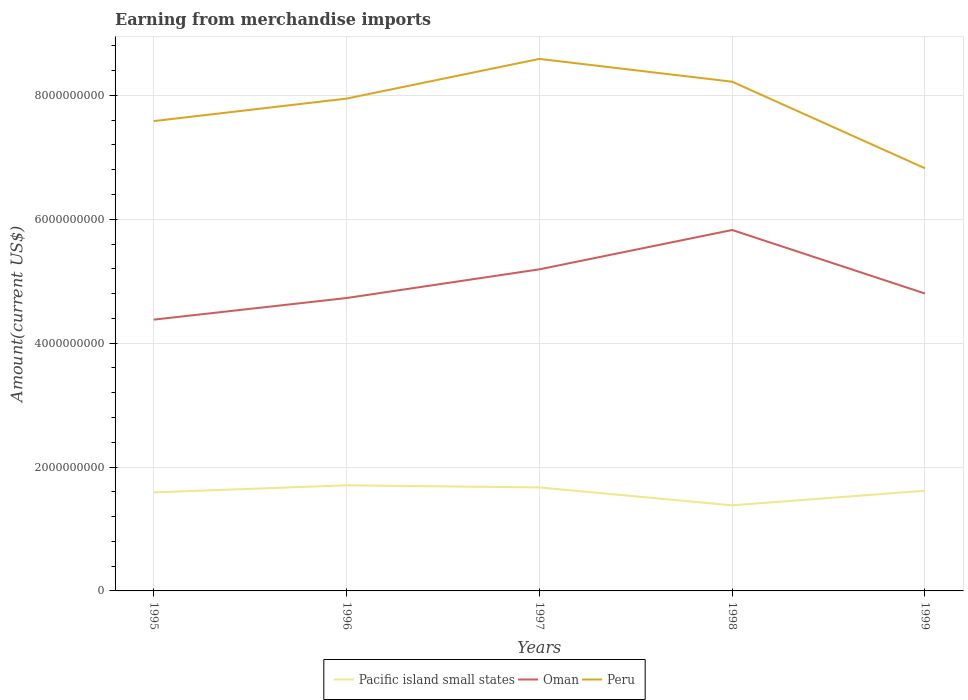How many different coloured lines are there?
Make the answer very short. 3. Does the line corresponding to Oman intersect with the line corresponding to Peru?
Keep it short and to the point. No. Is the number of lines equal to the number of legend labels?
Your answer should be very brief. Yes. Across all years, what is the maximum amount earned from merchandise imports in Pacific island small states?
Keep it short and to the point. 1.38e+09. In which year was the amount earned from merchandise imports in Pacific island small states maximum?
Your answer should be compact. 1998. What is the total amount earned from merchandise imports in Pacific island small states in the graph?
Provide a succinct answer. 2.89e+08. What is the difference between the highest and the second highest amount earned from merchandise imports in Oman?
Your answer should be compact. 1.45e+09. What is the difference between the highest and the lowest amount earned from merchandise imports in Pacific island small states?
Offer a terse response. 3. How many years are there in the graph?
Give a very brief answer. 5. What is the difference between two consecutive major ticks on the Y-axis?
Give a very brief answer. 2.00e+09. Does the graph contain any zero values?
Keep it short and to the point. No. Does the graph contain grids?
Provide a succinct answer. Yes. How are the legend labels stacked?
Keep it short and to the point. Horizontal. What is the title of the graph?
Make the answer very short. Earning from merchandise imports. What is the label or title of the X-axis?
Provide a short and direct response. Years. What is the label or title of the Y-axis?
Ensure brevity in your answer.  Amount(current US$). What is the Amount(current US$) in Pacific island small states in 1995?
Your answer should be compact. 1.59e+09. What is the Amount(current US$) in Oman in 1995?
Offer a terse response. 4.38e+09. What is the Amount(current US$) of Peru in 1995?
Your answer should be very brief. 7.58e+09. What is the Amount(current US$) of Pacific island small states in 1996?
Your answer should be very brief. 1.70e+09. What is the Amount(current US$) of Oman in 1996?
Your answer should be very brief. 4.73e+09. What is the Amount(current US$) of Peru in 1996?
Make the answer very short. 7.95e+09. What is the Amount(current US$) of Pacific island small states in 1997?
Your answer should be compact. 1.67e+09. What is the Amount(current US$) of Oman in 1997?
Your answer should be compact. 5.19e+09. What is the Amount(current US$) in Peru in 1997?
Your response must be concise. 8.59e+09. What is the Amount(current US$) of Pacific island small states in 1998?
Make the answer very short. 1.38e+09. What is the Amount(current US$) of Oman in 1998?
Offer a very short reply. 5.83e+09. What is the Amount(current US$) in Peru in 1998?
Ensure brevity in your answer.  8.22e+09. What is the Amount(current US$) in Pacific island small states in 1999?
Offer a very short reply. 1.62e+09. What is the Amount(current US$) of Oman in 1999?
Keep it short and to the point. 4.80e+09. What is the Amount(current US$) of Peru in 1999?
Your response must be concise. 6.82e+09. Across all years, what is the maximum Amount(current US$) in Pacific island small states?
Your answer should be compact. 1.70e+09. Across all years, what is the maximum Amount(current US$) in Oman?
Keep it short and to the point. 5.83e+09. Across all years, what is the maximum Amount(current US$) of Peru?
Offer a very short reply. 8.59e+09. Across all years, what is the minimum Amount(current US$) of Pacific island small states?
Your answer should be compact. 1.38e+09. Across all years, what is the minimum Amount(current US$) of Oman?
Your answer should be very brief. 4.38e+09. Across all years, what is the minimum Amount(current US$) in Peru?
Your response must be concise. 6.82e+09. What is the total Amount(current US$) in Pacific island small states in the graph?
Your answer should be very brief. 7.97e+09. What is the total Amount(current US$) of Oman in the graph?
Give a very brief answer. 2.49e+1. What is the total Amount(current US$) in Peru in the graph?
Make the answer very short. 3.92e+1. What is the difference between the Amount(current US$) of Pacific island small states in 1995 and that in 1996?
Give a very brief answer. -1.14e+08. What is the difference between the Amount(current US$) in Oman in 1995 and that in 1996?
Provide a short and direct response. -3.49e+08. What is the difference between the Amount(current US$) in Peru in 1995 and that in 1996?
Make the answer very short. -3.63e+08. What is the difference between the Amount(current US$) of Pacific island small states in 1995 and that in 1997?
Provide a succinct answer. -7.98e+07. What is the difference between the Amount(current US$) in Oman in 1995 and that in 1997?
Provide a succinct answer. -8.12e+08. What is the difference between the Amount(current US$) in Peru in 1995 and that in 1997?
Offer a very short reply. -1.00e+09. What is the difference between the Amount(current US$) of Pacific island small states in 1995 and that in 1998?
Make the answer very short. 2.09e+08. What is the difference between the Amount(current US$) in Oman in 1995 and that in 1998?
Give a very brief answer. -1.45e+09. What is the difference between the Amount(current US$) in Peru in 1995 and that in 1998?
Provide a short and direct response. -6.36e+08. What is the difference between the Amount(current US$) in Pacific island small states in 1995 and that in 1999?
Your response must be concise. -2.67e+07. What is the difference between the Amount(current US$) in Oman in 1995 and that in 1999?
Your answer should be compact. -4.22e+08. What is the difference between the Amount(current US$) of Peru in 1995 and that in 1999?
Provide a succinct answer. 7.61e+08. What is the difference between the Amount(current US$) of Pacific island small states in 1996 and that in 1997?
Make the answer very short. 3.42e+07. What is the difference between the Amount(current US$) in Oman in 1996 and that in 1997?
Make the answer very short. -4.63e+08. What is the difference between the Amount(current US$) in Peru in 1996 and that in 1997?
Provide a succinct answer. -6.41e+08. What is the difference between the Amount(current US$) in Pacific island small states in 1996 and that in 1998?
Offer a terse response. 3.23e+08. What is the difference between the Amount(current US$) of Oman in 1996 and that in 1998?
Your response must be concise. -1.10e+09. What is the difference between the Amount(current US$) in Peru in 1996 and that in 1998?
Keep it short and to the point. -2.73e+08. What is the difference between the Amount(current US$) of Pacific island small states in 1996 and that in 1999?
Ensure brevity in your answer.  8.73e+07. What is the difference between the Amount(current US$) in Oman in 1996 and that in 1999?
Ensure brevity in your answer.  -7.30e+07. What is the difference between the Amount(current US$) in Peru in 1996 and that in 1999?
Provide a succinct answer. 1.12e+09. What is the difference between the Amount(current US$) of Pacific island small states in 1997 and that in 1998?
Your answer should be compact. 2.89e+08. What is the difference between the Amount(current US$) in Oman in 1997 and that in 1998?
Make the answer very short. -6.35e+08. What is the difference between the Amount(current US$) in Peru in 1997 and that in 1998?
Keep it short and to the point. 3.68e+08. What is the difference between the Amount(current US$) of Pacific island small states in 1997 and that in 1999?
Offer a terse response. 5.31e+07. What is the difference between the Amount(current US$) in Oman in 1997 and that in 1999?
Your answer should be compact. 3.90e+08. What is the difference between the Amount(current US$) of Peru in 1997 and that in 1999?
Offer a very short reply. 1.76e+09. What is the difference between the Amount(current US$) of Pacific island small states in 1998 and that in 1999?
Your answer should be compact. -2.35e+08. What is the difference between the Amount(current US$) of Oman in 1998 and that in 1999?
Your answer should be very brief. 1.02e+09. What is the difference between the Amount(current US$) in Peru in 1998 and that in 1999?
Keep it short and to the point. 1.40e+09. What is the difference between the Amount(current US$) of Pacific island small states in 1995 and the Amount(current US$) of Oman in 1996?
Give a very brief answer. -3.14e+09. What is the difference between the Amount(current US$) of Pacific island small states in 1995 and the Amount(current US$) of Peru in 1996?
Your response must be concise. -6.36e+09. What is the difference between the Amount(current US$) of Oman in 1995 and the Amount(current US$) of Peru in 1996?
Provide a succinct answer. -3.57e+09. What is the difference between the Amount(current US$) of Pacific island small states in 1995 and the Amount(current US$) of Oman in 1997?
Provide a succinct answer. -3.60e+09. What is the difference between the Amount(current US$) in Pacific island small states in 1995 and the Amount(current US$) in Peru in 1997?
Offer a very short reply. -7.00e+09. What is the difference between the Amount(current US$) in Oman in 1995 and the Amount(current US$) in Peru in 1997?
Your response must be concise. -4.21e+09. What is the difference between the Amount(current US$) of Pacific island small states in 1995 and the Amount(current US$) of Oman in 1998?
Your response must be concise. -4.24e+09. What is the difference between the Amount(current US$) in Pacific island small states in 1995 and the Amount(current US$) in Peru in 1998?
Make the answer very short. -6.63e+09. What is the difference between the Amount(current US$) of Oman in 1995 and the Amount(current US$) of Peru in 1998?
Your response must be concise. -3.84e+09. What is the difference between the Amount(current US$) of Pacific island small states in 1995 and the Amount(current US$) of Oman in 1999?
Your answer should be compact. -3.21e+09. What is the difference between the Amount(current US$) of Pacific island small states in 1995 and the Amount(current US$) of Peru in 1999?
Your response must be concise. -5.23e+09. What is the difference between the Amount(current US$) of Oman in 1995 and the Amount(current US$) of Peru in 1999?
Offer a very short reply. -2.44e+09. What is the difference between the Amount(current US$) of Pacific island small states in 1996 and the Amount(current US$) of Oman in 1997?
Give a very brief answer. -3.49e+09. What is the difference between the Amount(current US$) in Pacific island small states in 1996 and the Amount(current US$) in Peru in 1997?
Keep it short and to the point. -6.88e+09. What is the difference between the Amount(current US$) in Oman in 1996 and the Amount(current US$) in Peru in 1997?
Keep it short and to the point. -3.86e+09. What is the difference between the Amount(current US$) of Pacific island small states in 1996 and the Amount(current US$) of Oman in 1998?
Keep it short and to the point. -4.12e+09. What is the difference between the Amount(current US$) of Pacific island small states in 1996 and the Amount(current US$) of Peru in 1998?
Ensure brevity in your answer.  -6.52e+09. What is the difference between the Amount(current US$) in Oman in 1996 and the Amount(current US$) in Peru in 1998?
Provide a short and direct response. -3.49e+09. What is the difference between the Amount(current US$) in Pacific island small states in 1996 and the Amount(current US$) in Oman in 1999?
Give a very brief answer. -3.10e+09. What is the difference between the Amount(current US$) of Pacific island small states in 1996 and the Amount(current US$) of Peru in 1999?
Offer a terse response. -5.12e+09. What is the difference between the Amount(current US$) in Oman in 1996 and the Amount(current US$) in Peru in 1999?
Provide a succinct answer. -2.10e+09. What is the difference between the Amount(current US$) in Pacific island small states in 1997 and the Amount(current US$) in Oman in 1998?
Make the answer very short. -4.16e+09. What is the difference between the Amount(current US$) of Pacific island small states in 1997 and the Amount(current US$) of Peru in 1998?
Offer a terse response. -6.55e+09. What is the difference between the Amount(current US$) in Oman in 1997 and the Amount(current US$) in Peru in 1998?
Offer a very short reply. -3.03e+09. What is the difference between the Amount(current US$) of Pacific island small states in 1997 and the Amount(current US$) of Oman in 1999?
Provide a short and direct response. -3.13e+09. What is the difference between the Amount(current US$) of Pacific island small states in 1997 and the Amount(current US$) of Peru in 1999?
Provide a short and direct response. -5.15e+09. What is the difference between the Amount(current US$) of Oman in 1997 and the Amount(current US$) of Peru in 1999?
Provide a succinct answer. -1.63e+09. What is the difference between the Amount(current US$) of Pacific island small states in 1998 and the Amount(current US$) of Oman in 1999?
Ensure brevity in your answer.  -3.42e+09. What is the difference between the Amount(current US$) of Pacific island small states in 1998 and the Amount(current US$) of Peru in 1999?
Offer a very short reply. -5.44e+09. What is the difference between the Amount(current US$) of Oman in 1998 and the Amount(current US$) of Peru in 1999?
Make the answer very short. -9.97e+08. What is the average Amount(current US$) in Pacific island small states per year?
Give a very brief answer. 1.59e+09. What is the average Amount(current US$) in Oman per year?
Your answer should be compact. 4.98e+09. What is the average Amount(current US$) in Peru per year?
Your answer should be very brief. 7.83e+09. In the year 1995, what is the difference between the Amount(current US$) of Pacific island small states and Amount(current US$) of Oman?
Provide a succinct answer. -2.79e+09. In the year 1995, what is the difference between the Amount(current US$) of Pacific island small states and Amount(current US$) of Peru?
Offer a terse response. -5.99e+09. In the year 1995, what is the difference between the Amount(current US$) of Oman and Amount(current US$) of Peru?
Make the answer very short. -3.20e+09. In the year 1996, what is the difference between the Amount(current US$) in Pacific island small states and Amount(current US$) in Oman?
Provide a short and direct response. -3.02e+09. In the year 1996, what is the difference between the Amount(current US$) of Pacific island small states and Amount(current US$) of Peru?
Provide a short and direct response. -6.24e+09. In the year 1996, what is the difference between the Amount(current US$) of Oman and Amount(current US$) of Peru?
Your answer should be very brief. -3.22e+09. In the year 1997, what is the difference between the Amount(current US$) of Pacific island small states and Amount(current US$) of Oman?
Your response must be concise. -3.52e+09. In the year 1997, what is the difference between the Amount(current US$) of Pacific island small states and Amount(current US$) of Peru?
Your answer should be very brief. -6.92e+09. In the year 1997, what is the difference between the Amount(current US$) of Oman and Amount(current US$) of Peru?
Provide a short and direct response. -3.40e+09. In the year 1998, what is the difference between the Amount(current US$) of Pacific island small states and Amount(current US$) of Oman?
Your response must be concise. -4.44e+09. In the year 1998, what is the difference between the Amount(current US$) in Pacific island small states and Amount(current US$) in Peru?
Ensure brevity in your answer.  -6.84e+09. In the year 1998, what is the difference between the Amount(current US$) of Oman and Amount(current US$) of Peru?
Make the answer very short. -2.39e+09. In the year 1999, what is the difference between the Amount(current US$) of Pacific island small states and Amount(current US$) of Oman?
Offer a very short reply. -3.18e+09. In the year 1999, what is the difference between the Amount(current US$) in Pacific island small states and Amount(current US$) in Peru?
Provide a succinct answer. -5.21e+09. In the year 1999, what is the difference between the Amount(current US$) in Oman and Amount(current US$) in Peru?
Your response must be concise. -2.02e+09. What is the ratio of the Amount(current US$) of Pacific island small states in 1995 to that in 1996?
Offer a terse response. 0.93. What is the ratio of the Amount(current US$) in Oman in 1995 to that in 1996?
Provide a short and direct response. 0.93. What is the ratio of the Amount(current US$) in Peru in 1995 to that in 1996?
Your answer should be very brief. 0.95. What is the ratio of the Amount(current US$) in Pacific island small states in 1995 to that in 1997?
Make the answer very short. 0.95. What is the ratio of the Amount(current US$) of Oman in 1995 to that in 1997?
Ensure brevity in your answer.  0.84. What is the ratio of the Amount(current US$) in Peru in 1995 to that in 1997?
Your answer should be compact. 0.88. What is the ratio of the Amount(current US$) in Pacific island small states in 1995 to that in 1998?
Keep it short and to the point. 1.15. What is the ratio of the Amount(current US$) in Oman in 1995 to that in 1998?
Your answer should be compact. 0.75. What is the ratio of the Amount(current US$) in Peru in 1995 to that in 1998?
Offer a terse response. 0.92. What is the ratio of the Amount(current US$) of Pacific island small states in 1995 to that in 1999?
Your answer should be very brief. 0.98. What is the ratio of the Amount(current US$) in Oman in 1995 to that in 1999?
Offer a very short reply. 0.91. What is the ratio of the Amount(current US$) of Peru in 1995 to that in 1999?
Provide a succinct answer. 1.11. What is the ratio of the Amount(current US$) of Pacific island small states in 1996 to that in 1997?
Provide a short and direct response. 1.02. What is the ratio of the Amount(current US$) in Oman in 1996 to that in 1997?
Offer a very short reply. 0.91. What is the ratio of the Amount(current US$) in Peru in 1996 to that in 1997?
Provide a short and direct response. 0.93. What is the ratio of the Amount(current US$) in Pacific island small states in 1996 to that in 1998?
Give a very brief answer. 1.23. What is the ratio of the Amount(current US$) of Oman in 1996 to that in 1998?
Your answer should be very brief. 0.81. What is the ratio of the Amount(current US$) in Peru in 1996 to that in 1998?
Provide a succinct answer. 0.97. What is the ratio of the Amount(current US$) in Pacific island small states in 1996 to that in 1999?
Offer a terse response. 1.05. What is the ratio of the Amount(current US$) of Oman in 1996 to that in 1999?
Provide a short and direct response. 0.98. What is the ratio of the Amount(current US$) of Peru in 1996 to that in 1999?
Ensure brevity in your answer.  1.16. What is the ratio of the Amount(current US$) in Pacific island small states in 1997 to that in 1998?
Your answer should be very brief. 1.21. What is the ratio of the Amount(current US$) in Oman in 1997 to that in 1998?
Give a very brief answer. 0.89. What is the ratio of the Amount(current US$) of Peru in 1997 to that in 1998?
Make the answer very short. 1.04. What is the ratio of the Amount(current US$) in Pacific island small states in 1997 to that in 1999?
Give a very brief answer. 1.03. What is the ratio of the Amount(current US$) in Oman in 1997 to that in 1999?
Make the answer very short. 1.08. What is the ratio of the Amount(current US$) in Peru in 1997 to that in 1999?
Your answer should be very brief. 1.26. What is the ratio of the Amount(current US$) in Pacific island small states in 1998 to that in 1999?
Provide a succinct answer. 0.85. What is the ratio of the Amount(current US$) of Oman in 1998 to that in 1999?
Make the answer very short. 1.21. What is the ratio of the Amount(current US$) of Peru in 1998 to that in 1999?
Make the answer very short. 1.2. What is the difference between the highest and the second highest Amount(current US$) of Pacific island small states?
Make the answer very short. 3.42e+07. What is the difference between the highest and the second highest Amount(current US$) in Oman?
Provide a succinct answer. 6.35e+08. What is the difference between the highest and the second highest Amount(current US$) in Peru?
Your answer should be very brief. 3.68e+08. What is the difference between the highest and the lowest Amount(current US$) of Pacific island small states?
Your answer should be compact. 3.23e+08. What is the difference between the highest and the lowest Amount(current US$) of Oman?
Ensure brevity in your answer.  1.45e+09. What is the difference between the highest and the lowest Amount(current US$) of Peru?
Your response must be concise. 1.76e+09. 